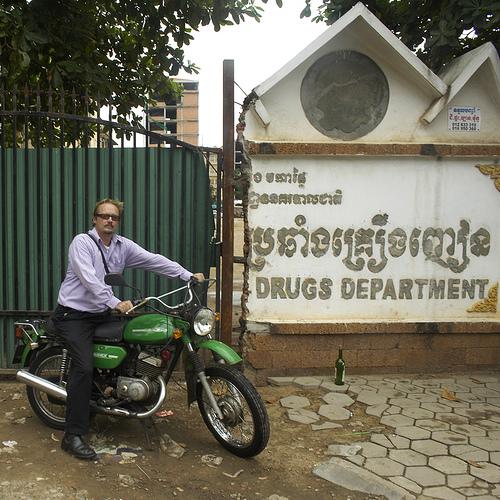Is this a professional quality sign?
Keep it brief. No. What is one language on the sign?
Quick response, please. English. How many broken stone pavers are in this picture?
Keep it brief. 6. What color is the bike?
Short answer required. Green. 